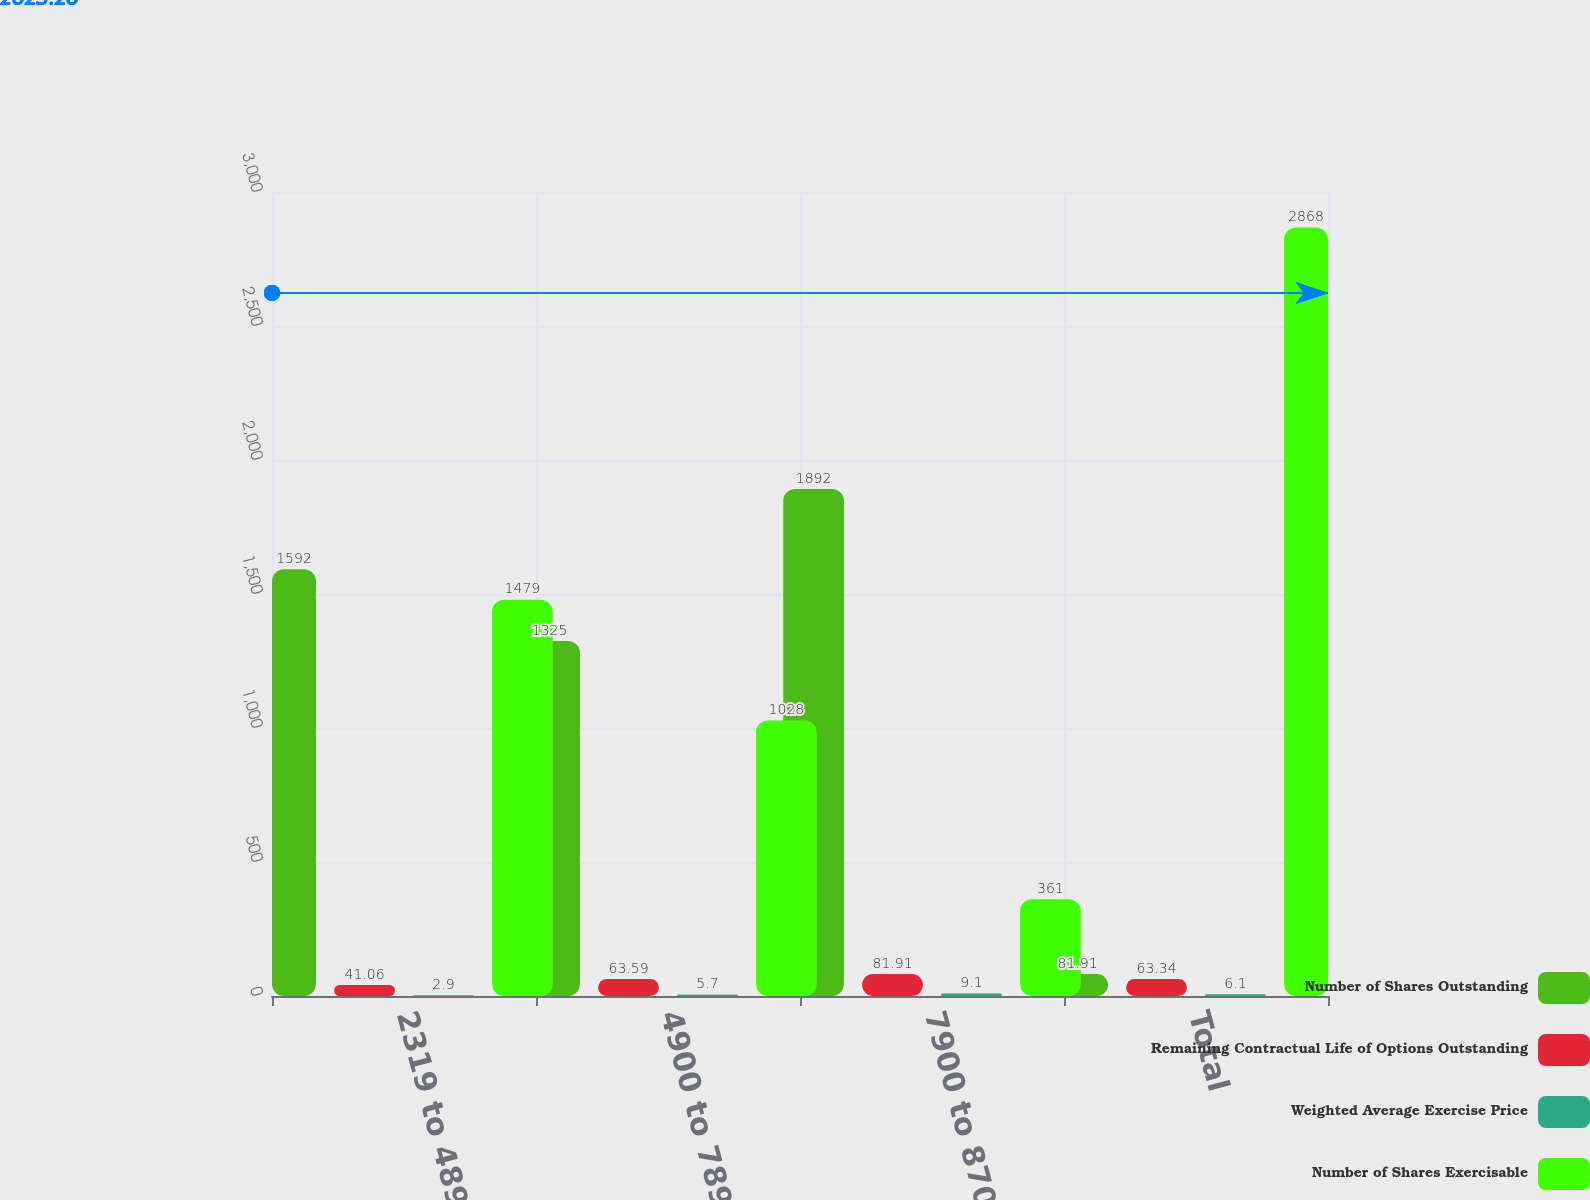Convert chart. <chart><loc_0><loc_0><loc_500><loc_500><stacked_bar_chart><ecel><fcel>2319 to 4899<fcel>4900 to 7899<fcel>7900 to 8706<fcel>Total<nl><fcel>Number of Shares Outstanding<fcel>1592<fcel>1325<fcel>1892<fcel>81.91<nl><fcel>Remaining Contractual Life of Options Outstanding<fcel>41.06<fcel>63.59<fcel>81.91<fcel>63.34<nl><fcel>Weighted Average Exercise Price<fcel>2.9<fcel>5.7<fcel>9.1<fcel>6.1<nl><fcel>Number of Shares Exercisable<fcel>1479<fcel>1028<fcel>361<fcel>2868<nl></chart> 